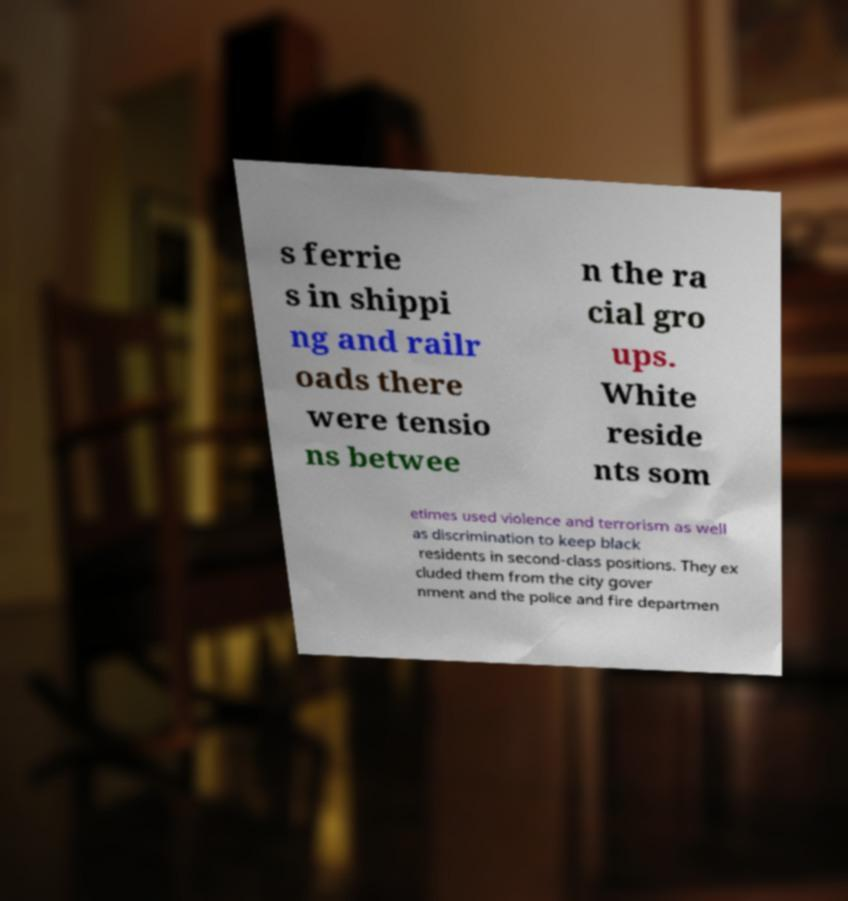Please read and relay the text visible in this image. What does it say? s ferrie s in shippi ng and railr oads there were tensio ns betwee n the ra cial gro ups. White reside nts som etimes used violence and terrorism as well as discrimination to keep black residents in second-class positions. They ex cluded them from the city gover nment and the police and fire departmen 